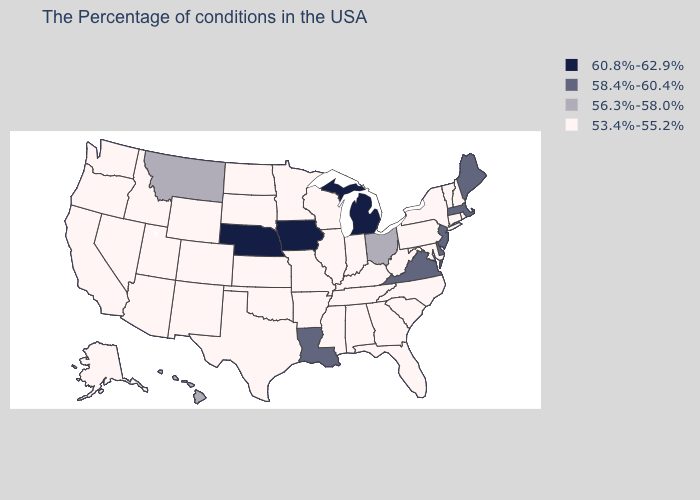Name the states that have a value in the range 56.3%-58.0%?
Give a very brief answer. Ohio, Montana, Hawaii. What is the lowest value in states that border Maine?
Be succinct. 53.4%-55.2%. Does the first symbol in the legend represent the smallest category?
Give a very brief answer. No. Does the first symbol in the legend represent the smallest category?
Write a very short answer. No. What is the value of Maine?
Short answer required. 58.4%-60.4%. What is the value of Mississippi?
Answer briefly. 53.4%-55.2%. What is the highest value in the MidWest ?
Keep it brief. 60.8%-62.9%. Does Iowa have the highest value in the USA?
Give a very brief answer. Yes. What is the value of Michigan?
Short answer required. 60.8%-62.9%. Name the states that have a value in the range 56.3%-58.0%?
Quick response, please. Ohio, Montana, Hawaii. Is the legend a continuous bar?
Answer briefly. No. Name the states that have a value in the range 56.3%-58.0%?
Quick response, please. Ohio, Montana, Hawaii. Among the states that border Montana , which have the highest value?
Short answer required. South Dakota, North Dakota, Wyoming, Idaho. Name the states that have a value in the range 56.3%-58.0%?
Quick response, please. Ohio, Montana, Hawaii. What is the value of Pennsylvania?
Be succinct. 53.4%-55.2%. 